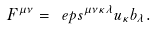Convert formula to latex. <formula><loc_0><loc_0><loc_500><loc_500>F ^ { \mu \nu } = \ e p s ^ { \mu \nu \kappa \lambda } u _ { \kappa } b _ { \lambda } .</formula> 